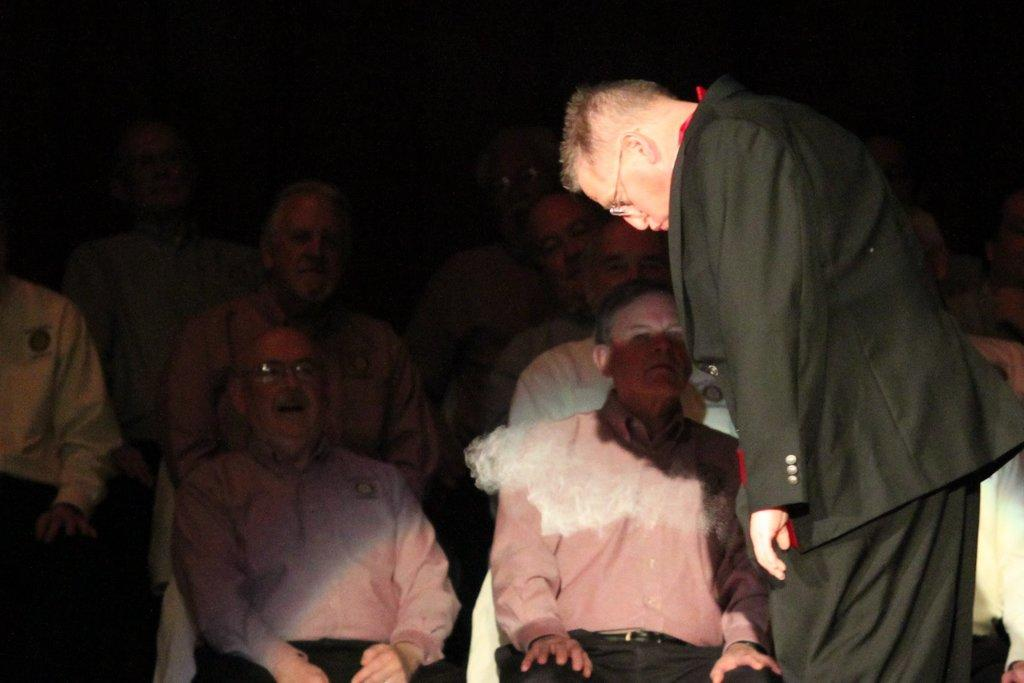What is the main subject of focus of the image? There is a person standing in the image. Are there any other people in the image? Yes, there are people sitting on chairs in the image. What can be observed about the lighting in the image? The background of the image is dark. What type of receipt can be seen on the person's desk in the image? There is no desk or receipt present in the image; it only features a person standing and people sitting on chairs. 